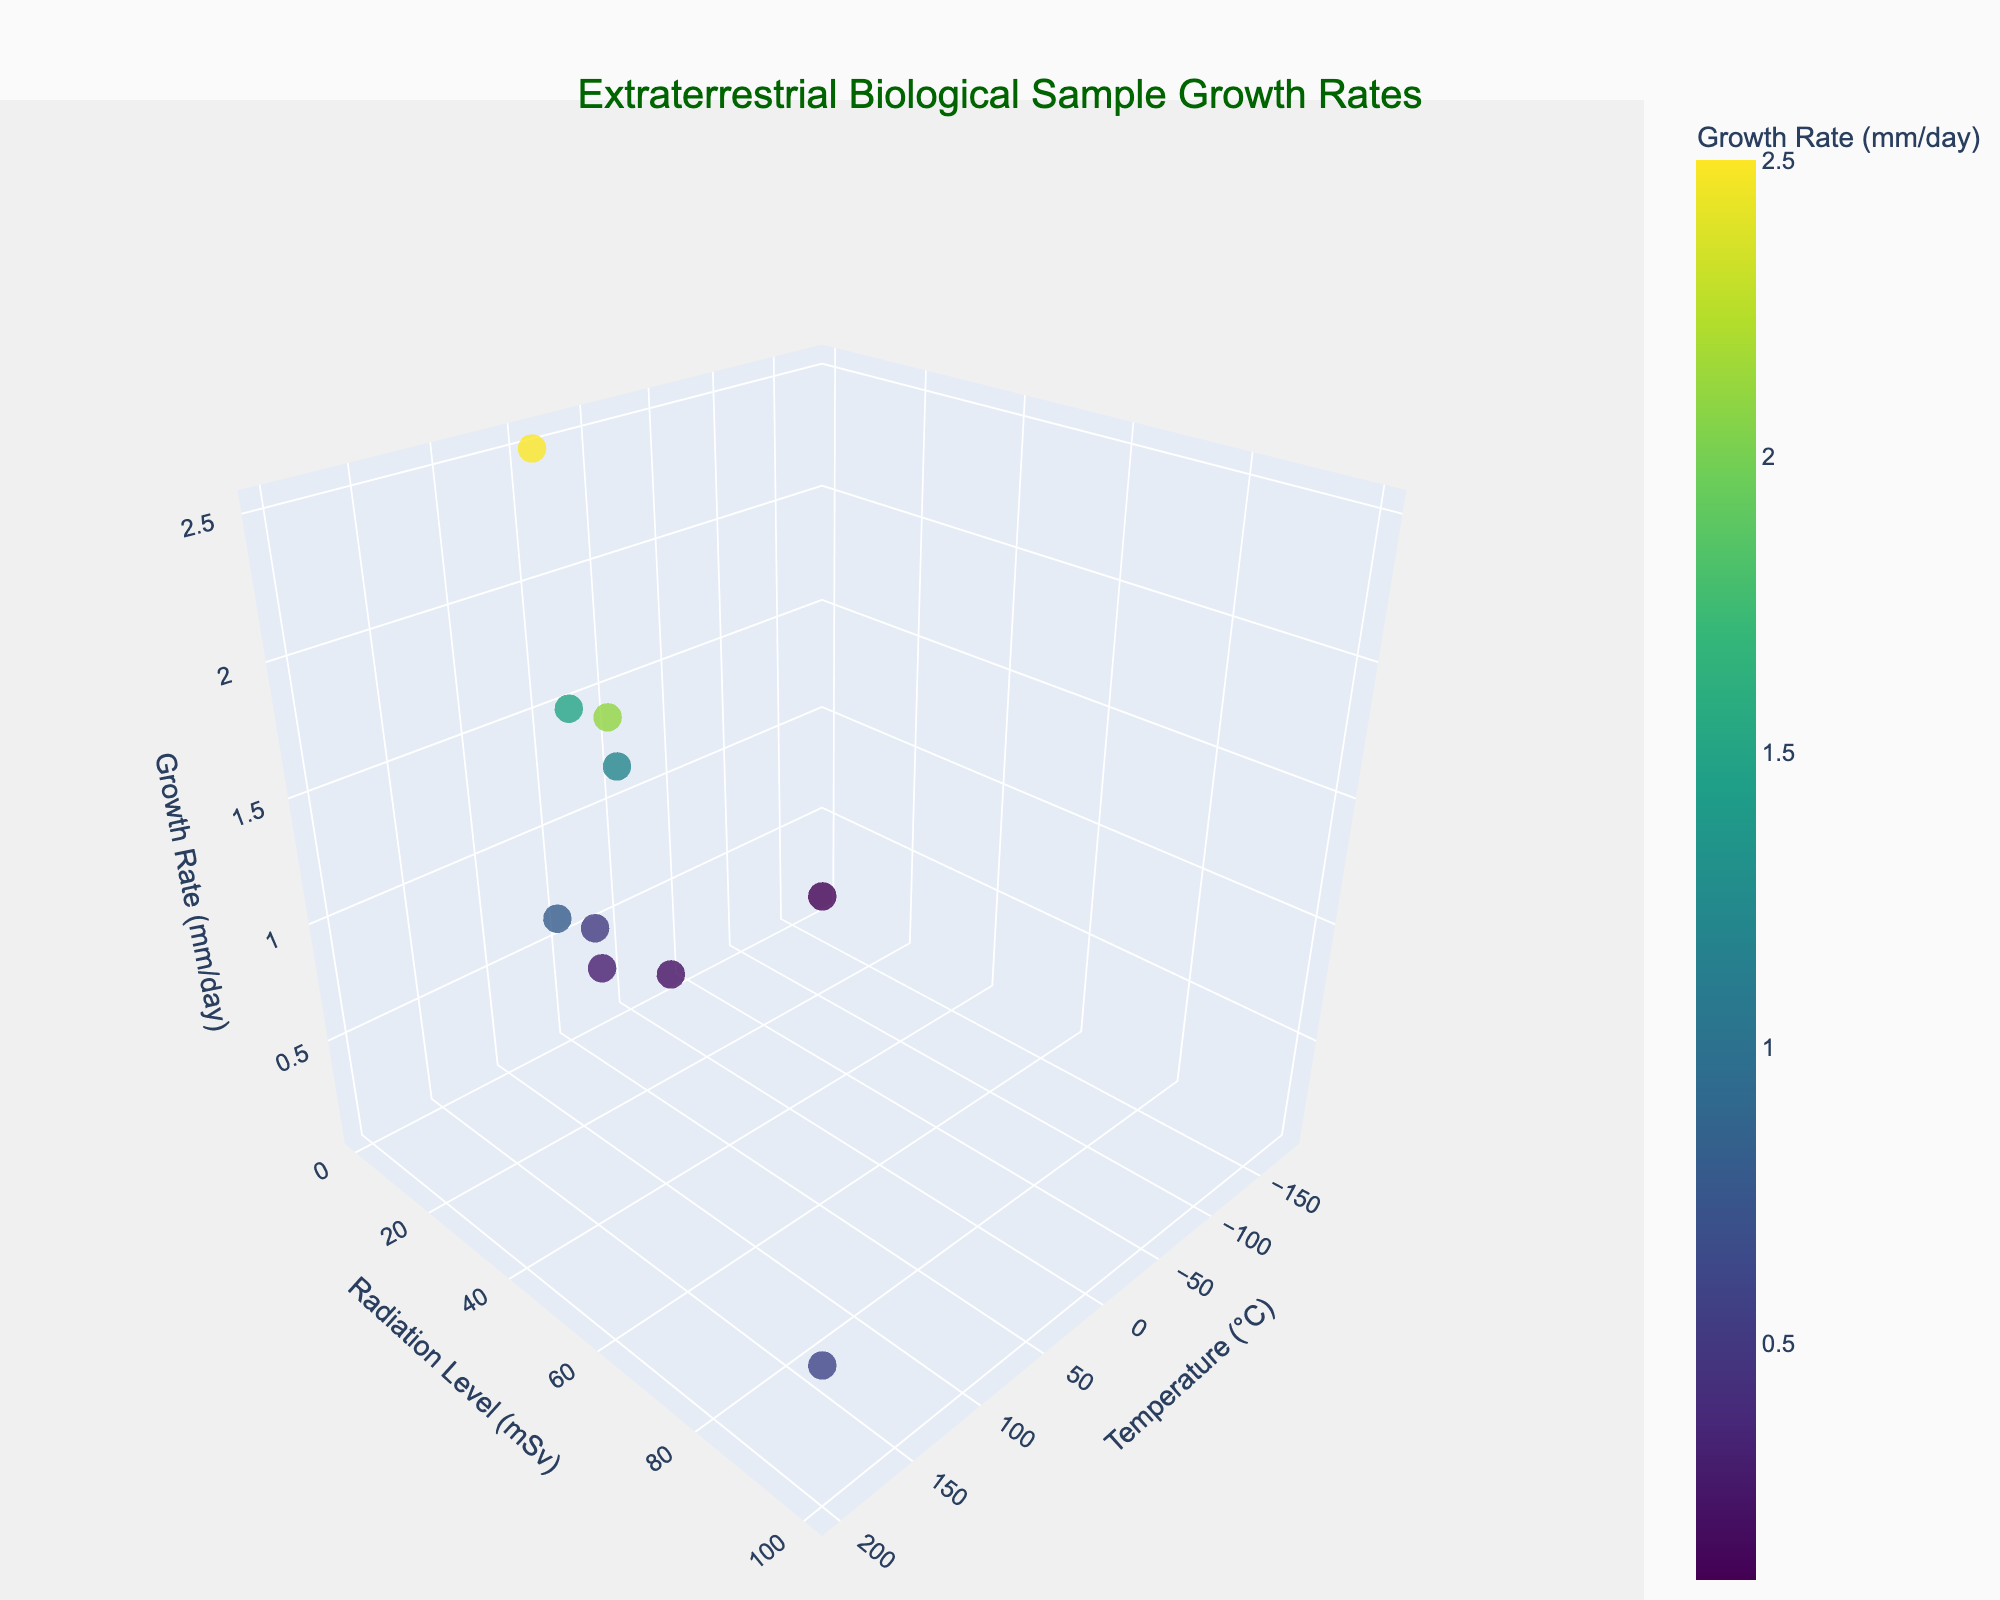What is the title of the figure? The title is displayed prominently at the top center of the figure.
Answer: "Extraterrestrial Biological Sample Growth Rates" What are the labels for the x, y, and z axes? The labels are shown along each axis in the figure. The x-axis is labeled "Temperature (°C)", the y-axis is labeled "Radiation Level (mSv)", and the z-axis is labeled "Growth Rate (mm/day)".
Answer: Temperature (°C), Radiation Level (mSv), Growth Rate (mm/day) How many data points are on the plot? Each marker represents a data point in the 3D scatter plot. By counting the markers, we see there are 10 data points.
Answer: 10 Which species has the highest growth rate and what is the value? By identifying the highest point on the z-axis and checking the hover text, we find that the highest growth rate is 2.5 mm/day, belonging to the "Gliese 667Cc Aquatic Microbe".
Answer: Gliese 667Cc Aquatic Microbe, 2.5 mm/day Which species grows the fastest under high temperatures and low radiation levels? High temperature is on the positive x-axis, and low radiation levels are on the low end of the y-axis. By finding the corresponding marker in this region, the species is "Jovian Gas Microbe".
Answer: Jovian Gas Microbe What is the range of temperatures represented in the plot? The temperatures range from the lowest to the highest x-axis values. The lowest temperature is -180°C (Titanian Methane Consumer) and the highest is 200°C (Sirius B Plasma Life Form).
Answer: -180°C to 200°C How does the growth rate trend with increasing radiation levels? By observing the z-coordinates of markers along the increasing y-axis value, we find that growth rates don't have a simple trend; they vary significantly. For instance, "Sirius B Plasma Life Form" has a low growth rate at high radiation, while the "Jovian Gas Microbe" has a higher growth rate at moderate radiation.
Answer: No clear trend What is the average radiation level for species with growth rates over 1 mm/day? First, identify the species with growth rates over 1 mm/day: "Jovian Gas Microbe", "Proxima Centauri Lichen", "Europan Subglacial Organism", and "Gliese 667Cc Aquatic Microbe". Their radiation levels are 50, 1, 2, and 0.5 respectively. Average = (50 + 1 + 2 + 0.5) / 4 = 13.875 mSv.
Answer: 13.875 mSv Which species can tolerate a wide range of atmospheric compositions? The species listed each tolerate different atmospheric compositions. By examining which species endure both high and low temperatures and radiation levels, we see "Jovian Gas Microbe" and "Sirius B Plasma Life Form" have very different conditions but survive in diverse atmospheres.
Answer: Jovian Gas Microbe, Sirius B Plasma Life Form 